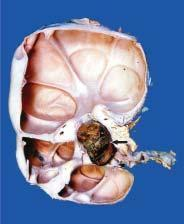what is seen to extend into renal p arenchyma, compressing the cortex as a thin rim at the periphery?
Answer the question using a single word or phrase. Cystic change 